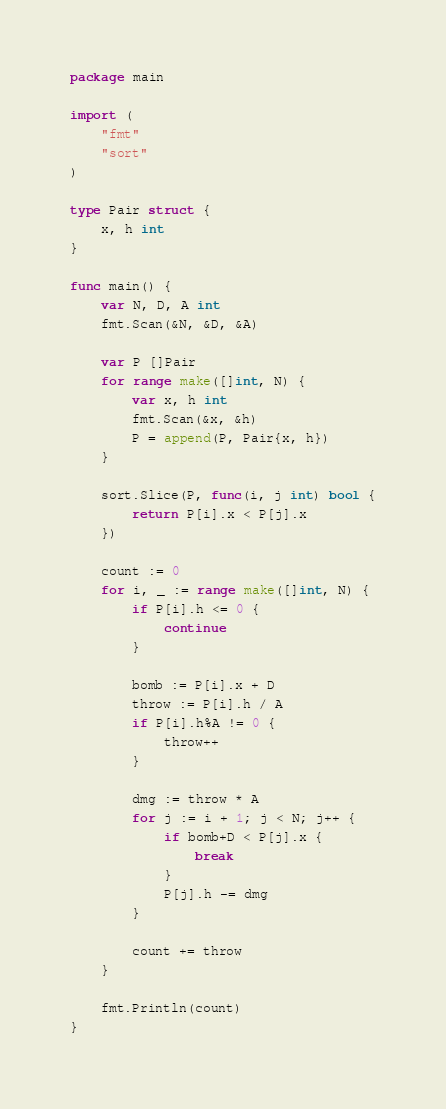<code> <loc_0><loc_0><loc_500><loc_500><_Go_>package main

import (
	"fmt"
	"sort"
)

type Pair struct {
	x, h int
}

func main() {
	var N, D, A int
	fmt.Scan(&N, &D, &A)

	var P []Pair
	for range make([]int, N) {
		var x, h int
		fmt.Scan(&x, &h)
		P = append(P, Pair{x, h})
	}

	sort.Slice(P, func(i, j int) bool {
		return P[i].x < P[j].x
	})

	count := 0
	for i, _ := range make([]int, N) {
		if P[i].h <= 0 {
			continue
		}

		bomb := P[i].x + D
		throw := P[i].h / A
		if P[i].h%A != 0 {
			throw++
		}

		dmg := throw * A
		for j := i + 1; j < N; j++ {
			if bomb+D < P[j].x {
				break
			}
			P[j].h -= dmg
		}

		count += throw
	}

	fmt.Println(count)
}
</code> 